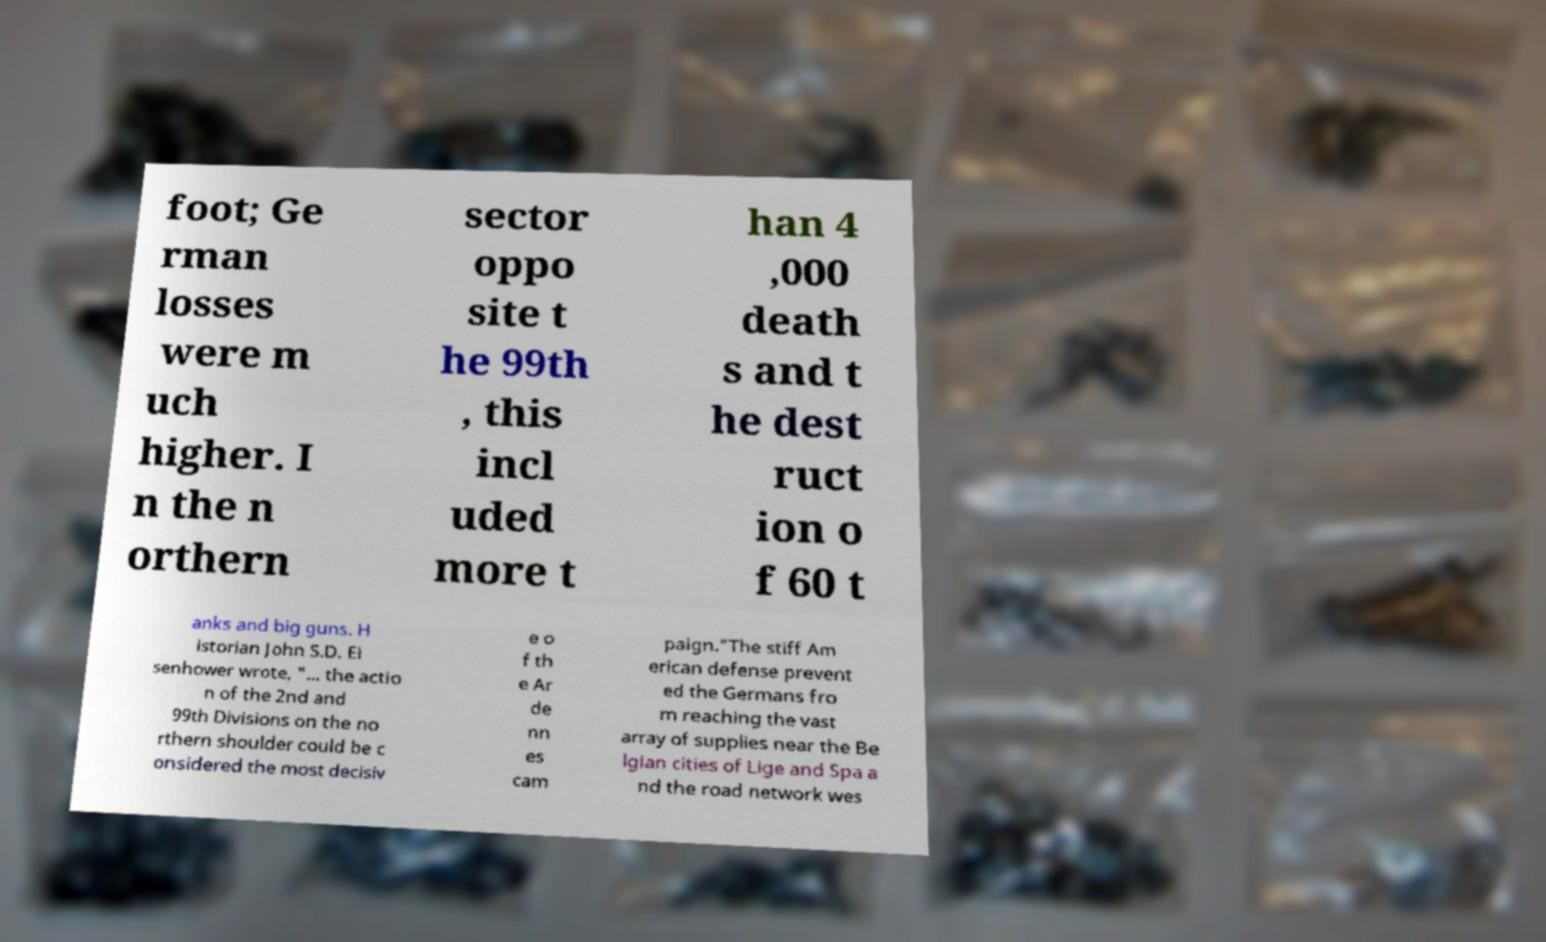There's text embedded in this image that I need extracted. Can you transcribe it verbatim? foot; Ge rman losses were m uch higher. I n the n orthern sector oppo site t he 99th , this incl uded more t han 4 ,000 death s and t he dest ruct ion o f 60 t anks and big guns. H istorian John S.D. Ei senhower wrote, "... the actio n of the 2nd and 99th Divisions on the no rthern shoulder could be c onsidered the most decisiv e o f th e Ar de nn es cam paign."The stiff Am erican defense prevent ed the Germans fro m reaching the vast array of supplies near the Be lgian cities of Lige and Spa a nd the road network wes 